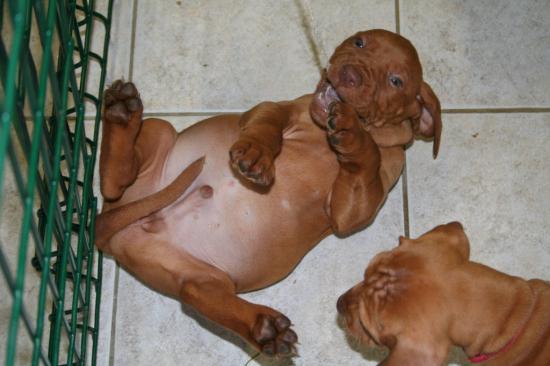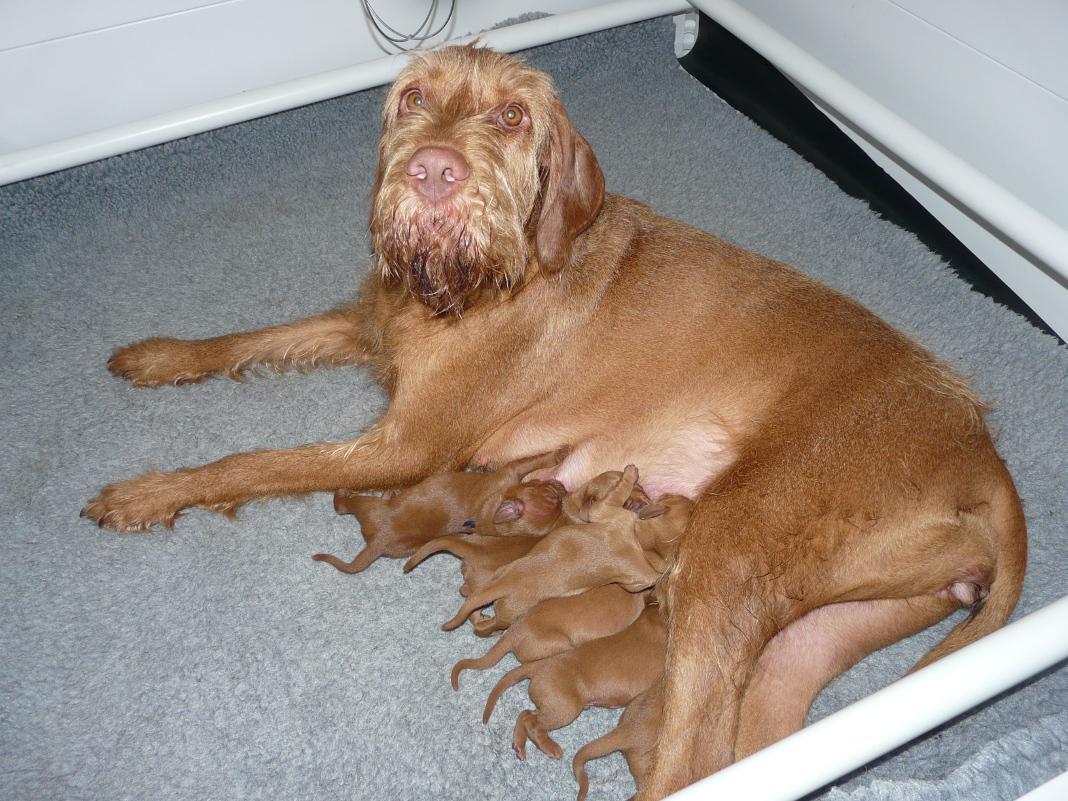The first image is the image on the left, the second image is the image on the right. Assess this claim about the two images: "there are two dogs in the image pair". Correct or not? Answer yes or no. No. The first image is the image on the left, the second image is the image on the right. Analyze the images presented: Is the assertion "The left image contains at least two dogs." valid? Answer yes or no. Yes. 